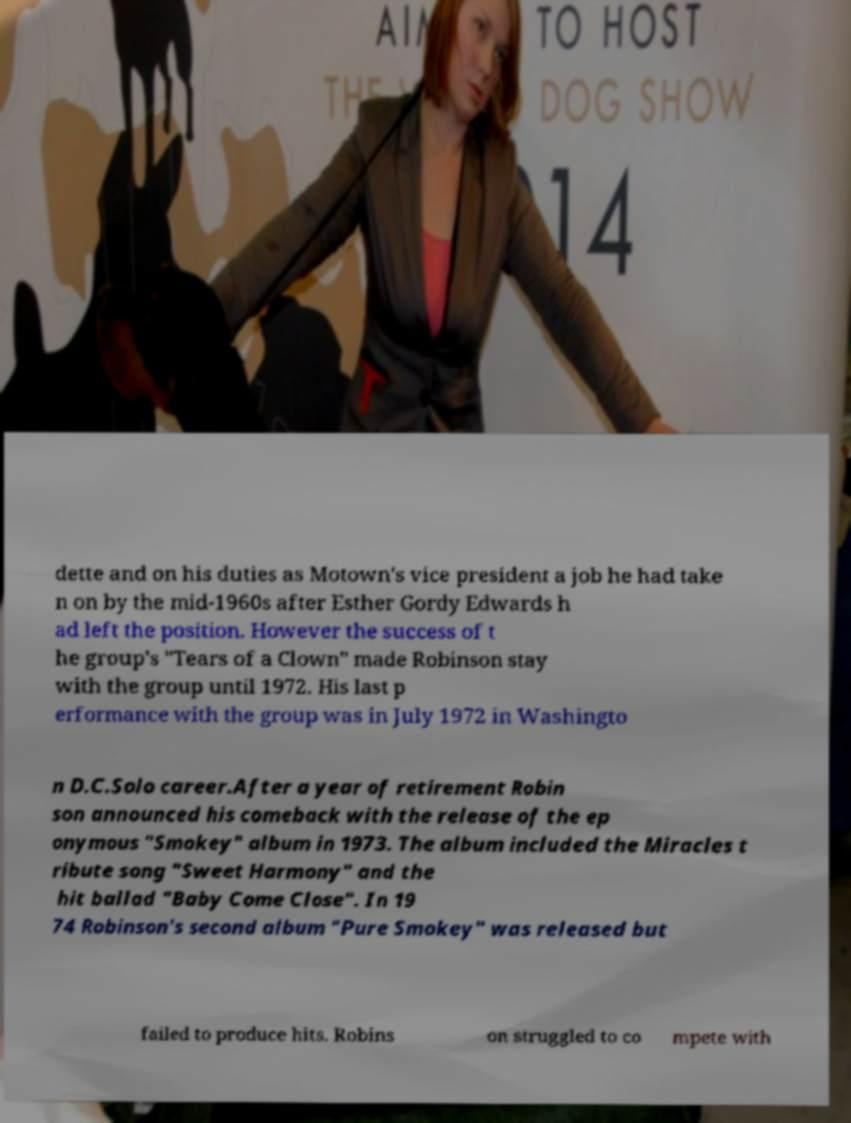Can you read and provide the text displayed in the image?This photo seems to have some interesting text. Can you extract and type it out for me? dette and on his duties as Motown's vice president a job he had take n on by the mid-1960s after Esther Gordy Edwards h ad left the position. However the success of t he group's "Tears of a Clown" made Robinson stay with the group until 1972. His last p erformance with the group was in July 1972 in Washingto n D.C.Solo career.After a year of retirement Robin son announced his comeback with the release of the ep onymous "Smokey" album in 1973. The album included the Miracles t ribute song "Sweet Harmony" and the hit ballad "Baby Come Close". In 19 74 Robinson's second album "Pure Smokey" was released but failed to produce hits. Robins on struggled to co mpete with 